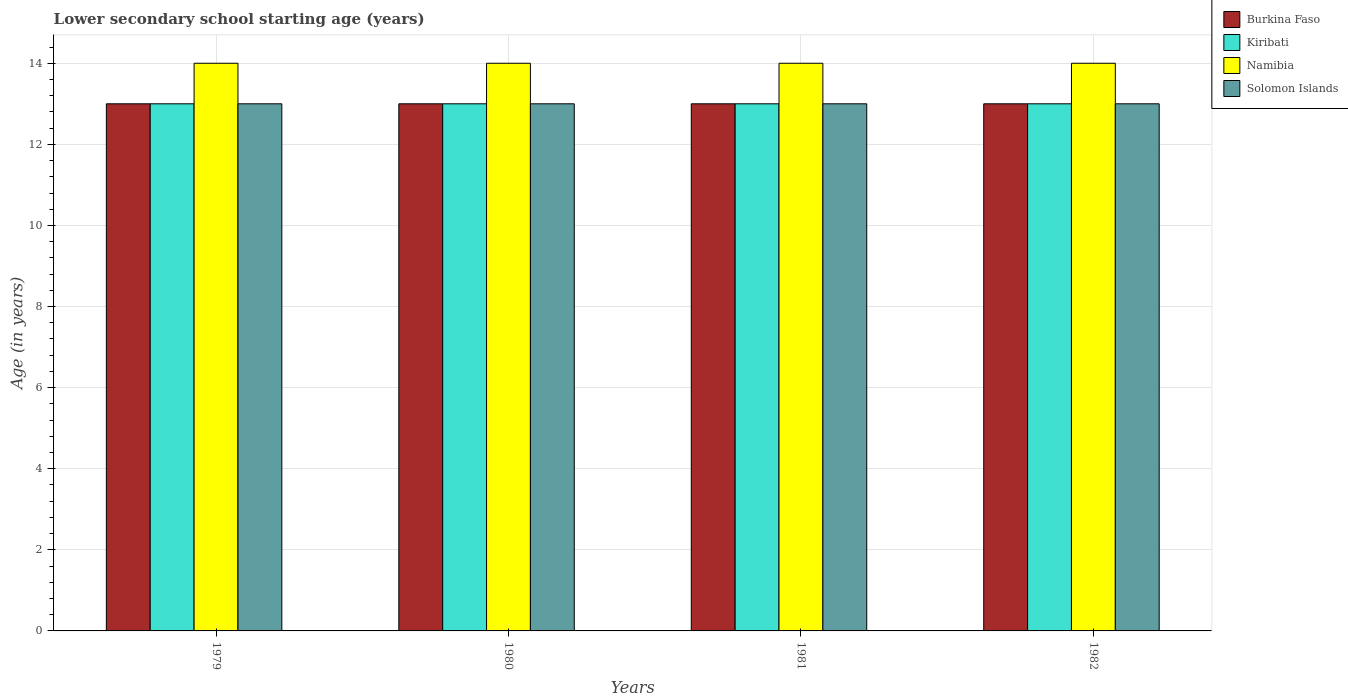How many groups of bars are there?
Make the answer very short. 4. Are the number of bars per tick equal to the number of legend labels?
Ensure brevity in your answer.  Yes. How many bars are there on the 2nd tick from the left?
Offer a very short reply. 4. What is the label of the 4th group of bars from the left?
Your answer should be very brief. 1982. In how many cases, is the number of bars for a given year not equal to the number of legend labels?
Provide a succinct answer. 0. What is the lower secondary school starting age of children in Burkina Faso in 1981?
Provide a short and direct response. 13. Across all years, what is the maximum lower secondary school starting age of children in Namibia?
Provide a succinct answer. 14. Across all years, what is the minimum lower secondary school starting age of children in Burkina Faso?
Give a very brief answer. 13. In which year was the lower secondary school starting age of children in Solomon Islands maximum?
Provide a succinct answer. 1979. In which year was the lower secondary school starting age of children in Kiribati minimum?
Your response must be concise. 1979. What is the total lower secondary school starting age of children in Solomon Islands in the graph?
Your answer should be compact. 52. What is the difference between the lower secondary school starting age of children in Burkina Faso in 1981 and the lower secondary school starting age of children in Kiribati in 1980?
Your answer should be very brief. 0. In how many years, is the lower secondary school starting age of children in Namibia greater than 10 years?
Ensure brevity in your answer.  4. What is the ratio of the lower secondary school starting age of children in Namibia in 1979 to that in 1981?
Provide a short and direct response. 1. Is the lower secondary school starting age of children in Namibia in 1980 less than that in 1982?
Give a very brief answer. No. Is the difference between the lower secondary school starting age of children in Burkina Faso in 1981 and 1982 greater than the difference between the lower secondary school starting age of children in Kiribati in 1981 and 1982?
Provide a succinct answer. No. In how many years, is the lower secondary school starting age of children in Namibia greater than the average lower secondary school starting age of children in Namibia taken over all years?
Offer a very short reply. 0. Is it the case that in every year, the sum of the lower secondary school starting age of children in Namibia and lower secondary school starting age of children in Solomon Islands is greater than the sum of lower secondary school starting age of children in Burkina Faso and lower secondary school starting age of children in Kiribati?
Offer a terse response. Yes. What does the 2nd bar from the left in 1980 represents?
Your answer should be compact. Kiribati. What does the 3rd bar from the right in 1981 represents?
Your answer should be very brief. Kiribati. How many bars are there?
Give a very brief answer. 16. Are all the bars in the graph horizontal?
Offer a very short reply. No. How many years are there in the graph?
Offer a very short reply. 4. Does the graph contain any zero values?
Provide a short and direct response. No. Does the graph contain grids?
Offer a very short reply. Yes. How many legend labels are there?
Offer a terse response. 4. What is the title of the graph?
Your answer should be compact. Lower secondary school starting age (years). What is the label or title of the X-axis?
Make the answer very short. Years. What is the label or title of the Y-axis?
Offer a very short reply. Age (in years). What is the Age (in years) of Burkina Faso in 1979?
Offer a terse response. 13. What is the Age (in years) in Kiribati in 1979?
Your answer should be very brief. 13. What is the Age (in years) in Namibia in 1979?
Offer a very short reply. 14. What is the Age (in years) of Solomon Islands in 1979?
Keep it short and to the point. 13. What is the Age (in years) in Burkina Faso in 1980?
Ensure brevity in your answer.  13. What is the Age (in years) in Namibia in 1980?
Your answer should be very brief. 14. What is the Age (in years) in Burkina Faso in 1981?
Ensure brevity in your answer.  13. What is the Age (in years) of Kiribati in 1981?
Your response must be concise. 13. What is the Age (in years) of Solomon Islands in 1981?
Your answer should be compact. 13. What is the Age (in years) of Burkina Faso in 1982?
Offer a terse response. 13. What is the Age (in years) in Kiribati in 1982?
Provide a succinct answer. 13. Across all years, what is the maximum Age (in years) of Namibia?
Make the answer very short. 14. Across all years, what is the minimum Age (in years) of Solomon Islands?
Your response must be concise. 13. What is the total Age (in years) of Burkina Faso in the graph?
Offer a terse response. 52. What is the total Age (in years) in Namibia in the graph?
Keep it short and to the point. 56. What is the difference between the Age (in years) of Burkina Faso in 1979 and that in 1980?
Make the answer very short. 0. What is the difference between the Age (in years) of Kiribati in 1979 and that in 1980?
Your answer should be very brief. 0. What is the difference between the Age (in years) in Solomon Islands in 1979 and that in 1980?
Your response must be concise. 0. What is the difference between the Age (in years) in Kiribati in 1979 and that in 1981?
Give a very brief answer. 0. What is the difference between the Age (in years) of Namibia in 1979 and that in 1981?
Make the answer very short. 0. What is the difference between the Age (in years) of Solomon Islands in 1979 and that in 1981?
Provide a short and direct response. 0. What is the difference between the Age (in years) in Kiribati in 1979 and that in 1982?
Give a very brief answer. 0. What is the difference between the Age (in years) in Namibia in 1979 and that in 1982?
Your answer should be very brief. 0. What is the difference between the Age (in years) of Burkina Faso in 1980 and that in 1981?
Ensure brevity in your answer.  0. What is the difference between the Age (in years) in Burkina Faso in 1980 and that in 1982?
Keep it short and to the point. 0. What is the difference between the Age (in years) in Kiribati in 1980 and that in 1982?
Give a very brief answer. 0. What is the difference between the Age (in years) in Namibia in 1979 and the Age (in years) in Solomon Islands in 1980?
Your answer should be compact. 1. What is the difference between the Age (in years) in Burkina Faso in 1979 and the Age (in years) in Namibia in 1981?
Provide a succinct answer. -1. What is the difference between the Age (in years) in Namibia in 1979 and the Age (in years) in Solomon Islands in 1981?
Offer a very short reply. 1. What is the difference between the Age (in years) in Burkina Faso in 1979 and the Age (in years) in Kiribati in 1982?
Offer a very short reply. 0. What is the difference between the Age (in years) of Burkina Faso in 1979 and the Age (in years) of Solomon Islands in 1982?
Provide a short and direct response. 0. What is the difference between the Age (in years) of Namibia in 1979 and the Age (in years) of Solomon Islands in 1982?
Give a very brief answer. 1. What is the difference between the Age (in years) of Burkina Faso in 1980 and the Age (in years) of Namibia in 1981?
Offer a very short reply. -1. What is the difference between the Age (in years) in Kiribati in 1980 and the Age (in years) in Namibia in 1981?
Offer a very short reply. -1. What is the difference between the Age (in years) of Namibia in 1980 and the Age (in years) of Solomon Islands in 1981?
Make the answer very short. 1. What is the difference between the Age (in years) of Burkina Faso in 1980 and the Age (in years) of Kiribati in 1982?
Your response must be concise. 0. What is the difference between the Age (in years) in Burkina Faso in 1980 and the Age (in years) in Namibia in 1982?
Make the answer very short. -1. What is the difference between the Age (in years) of Burkina Faso in 1980 and the Age (in years) of Solomon Islands in 1982?
Your answer should be compact. 0. What is the difference between the Age (in years) in Kiribati in 1980 and the Age (in years) in Namibia in 1982?
Your answer should be compact. -1. What is the difference between the Age (in years) of Kiribati in 1980 and the Age (in years) of Solomon Islands in 1982?
Give a very brief answer. 0. What is the difference between the Age (in years) in Burkina Faso in 1981 and the Age (in years) in Namibia in 1982?
Provide a short and direct response. -1. What is the difference between the Age (in years) in Burkina Faso in 1981 and the Age (in years) in Solomon Islands in 1982?
Keep it short and to the point. 0. What is the difference between the Age (in years) of Kiribati in 1981 and the Age (in years) of Namibia in 1982?
Make the answer very short. -1. What is the difference between the Age (in years) in Namibia in 1981 and the Age (in years) in Solomon Islands in 1982?
Your response must be concise. 1. What is the average Age (in years) of Burkina Faso per year?
Provide a short and direct response. 13. What is the average Age (in years) in Kiribati per year?
Your answer should be very brief. 13. What is the average Age (in years) in Namibia per year?
Offer a very short reply. 14. What is the average Age (in years) in Solomon Islands per year?
Give a very brief answer. 13. In the year 1979, what is the difference between the Age (in years) in Burkina Faso and Age (in years) in Kiribati?
Give a very brief answer. 0. In the year 1979, what is the difference between the Age (in years) of Burkina Faso and Age (in years) of Namibia?
Make the answer very short. -1. In the year 1979, what is the difference between the Age (in years) of Burkina Faso and Age (in years) of Solomon Islands?
Your response must be concise. 0. In the year 1979, what is the difference between the Age (in years) of Kiribati and Age (in years) of Namibia?
Give a very brief answer. -1. In the year 1979, what is the difference between the Age (in years) of Kiribati and Age (in years) of Solomon Islands?
Keep it short and to the point. 0. In the year 1979, what is the difference between the Age (in years) in Namibia and Age (in years) in Solomon Islands?
Your answer should be very brief. 1. In the year 1980, what is the difference between the Age (in years) in Kiribati and Age (in years) in Namibia?
Give a very brief answer. -1. In the year 1981, what is the difference between the Age (in years) in Burkina Faso and Age (in years) in Kiribati?
Provide a short and direct response. 0. In the year 1981, what is the difference between the Age (in years) of Burkina Faso and Age (in years) of Namibia?
Provide a short and direct response. -1. In the year 1981, what is the difference between the Age (in years) of Kiribati and Age (in years) of Namibia?
Offer a terse response. -1. In the year 1981, what is the difference between the Age (in years) of Kiribati and Age (in years) of Solomon Islands?
Your response must be concise. 0. In the year 1982, what is the difference between the Age (in years) in Kiribati and Age (in years) in Namibia?
Offer a terse response. -1. In the year 1982, what is the difference between the Age (in years) in Namibia and Age (in years) in Solomon Islands?
Keep it short and to the point. 1. What is the ratio of the Age (in years) in Kiribati in 1979 to that in 1981?
Offer a terse response. 1. What is the ratio of the Age (in years) of Namibia in 1979 to that in 1981?
Your answer should be very brief. 1. What is the ratio of the Age (in years) in Burkina Faso in 1979 to that in 1982?
Your answer should be very brief. 1. What is the ratio of the Age (in years) of Kiribati in 1979 to that in 1982?
Make the answer very short. 1. What is the ratio of the Age (in years) in Namibia in 1979 to that in 1982?
Provide a succinct answer. 1. What is the ratio of the Age (in years) in Solomon Islands in 1979 to that in 1982?
Ensure brevity in your answer.  1. What is the ratio of the Age (in years) of Burkina Faso in 1980 to that in 1981?
Offer a terse response. 1. What is the ratio of the Age (in years) in Kiribati in 1980 to that in 1981?
Offer a very short reply. 1. What is the ratio of the Age (in years) of Namibia in 1980 to that in 1981?
Your answer should be very brief. 1. What is the ratio of the Age (in years) in Kiribati in 1980 to that in 1982?
Your answer should be compact. 1. What is the ratio of the Age (in years) in Solomon Islands in 1980 to that in 1982?
Offer a very short reply. 1. What is the ratio of the Age (in years) in Burkina Faso in 1981 to that in 1982?
Make the answer very short. 1. What is the ratio of the Age (in years) in Namibia in 1981 to that in 1982?
Offer a very short reply. 1. What is the ratio of the Age (in years) in Solomon Islands in 1981 to that in 1982?
Keep it short and to the point. 1. What is the difference between the highest and the second highest Age (in years) of Kiribati?
Provide a succinct answer. 0. What is the difference between the highest and the second highest Age (in years) in Solomon Islands?
Offer a very short reply. 0. 